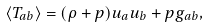<formula> <loc_0><loc_0><loc_500><loc_500>\langle T _ { a b } \rangle = ( \rho + p ) u _ { a } u _ { b } + p g _ { a b } ,</formula> 